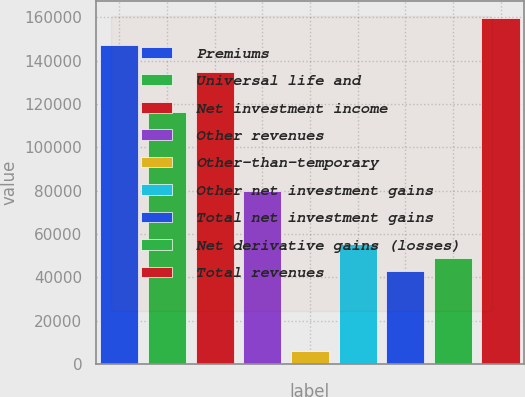<chart> <loc_0><loc_0><loc_500><loc_500><bar_chart><fcel>Premiums<fcel>Universal life and<fcel>Net investment income<fcel>Other revenues<fcel>Other-than-temporary<fcel>Other net investment gains<fcel>Total net investment gains<fcel>Net derivative gains (losses)<fcel>Total revenues<nl><fcel>147221<fcel>116550<fcel>134953<fcel>79745.4<fcel>6135.63<fcel>55208.8<fcel>42940.5<fcel>49074.7<fcel>159489<nl></chart> 